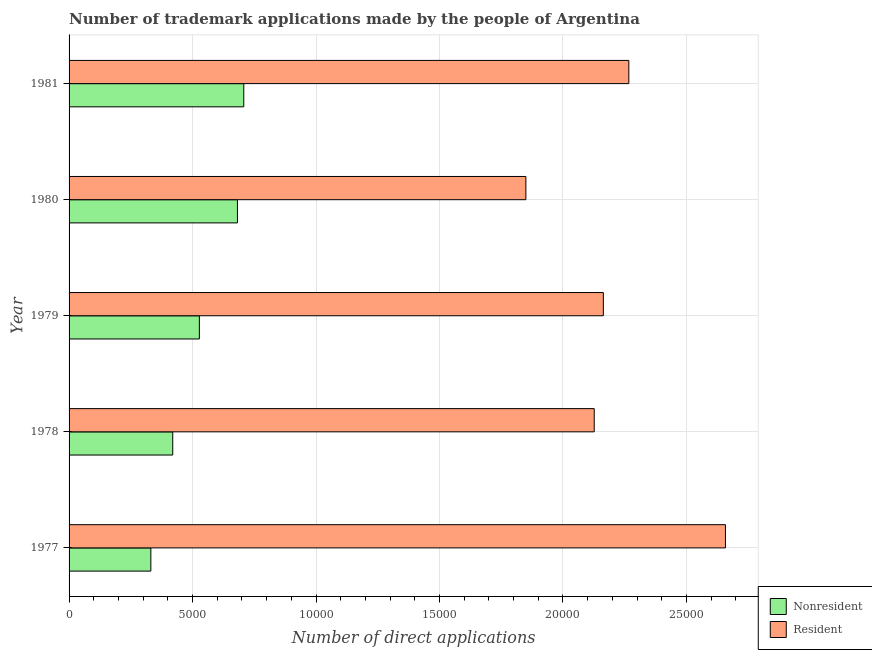How many groups of bars are there?
Your answer should be compact. 5. How many bars are there on the 5th tick from the bottom?
Offer a terse response. 2. What is the label of the 2nd group of bars from the top?
Your answer should be compact. 1980. What is the number of trademark applications made by residents in 1977?
Provide a succinct answer. 2.66e+04. Across all years, what is the maximum number of trademark applications made by residents?
Provide a succinct answer. 2.66e+04. Across all years, what is the minimum number of trademark applications made by non residents?
Your answer should be very brief. 3311. In which year was the number of trademark applications made by residents maximum?
Give a very brief answer. 1977. What is the total number of trademark applications made by residents in the graph?
Offer a very short reply. 1.11e+05. What is the difference between the number of trademark applications made by non residents in 1978 and that in 1980?
Your answer should be compact. -2620. What is the difference between the number of trademark applications made by residents in 1977 and the number of trademark applications made by non residents in 1978?
Keep it short and to the point. 2.24e+04. What is the average number of trademark applications made by non residents per year?
Your response must be concise. 5335.6. In the year 1979, what is the difference between the number of trademark applications made by non residents and number of trademark applications made by residents?
Make the answer very short. -1.64e+04. What is the ratio of the number of trademark applications made by residents in 1977 to that in 1981?
Your answer should be very brief. 1.17. Is the number of trademark applications made by residents in 1977 less than that in 1978?
Offer a very short reply. No. Is the difference between the number of trademark applications made by non residents in 1979 and 1981 greater than the difference between the number of trademark applications made by residents in 1979 and 1981?
Keep it short and to the point. No. What is the difference between the highest and the second highest number of trademark applications made by residents?
Ensure brevity in your answer.  3912. What is the difference between the highest and the lowest number of trademark applications made by residents?
Give a very brief answer. 8081. Is the sum of the number of trademark applications made by non residents in 1978 and 1981 greater than the maximum number of trademark applications made by residents across all years?
Offer a terse response. No. What does the 2nd bar from the top in 1977 represents?
Ensure brevity in your answer.  Nonresident. What does the 1st bar from the bottom in 1979 represents?
Provide a short and direct response. Nonresident. How many years are there in the graph?
Your answer should be very brief. 5. Does the graph contain any zero values?
Offer a terse response. No. How many legend labels are there?
Your response must be concise. 2. How are the legend labels stacked?
Keep it short and to the point. Vertical. What is the title of the graph?
Make the answer very short. Number of trademark applications made by the people of Argentina. What is the label or title of the X-axis?
Your answer should be very brief. Number of direct applications. What is the Number of direct applications of Nonresident in 1977?
Your answer should be very brief. 3311. What is the Number of direct applications of Resident in 1977?
Your answer should be compact. 2.66e+04. What is the Number of direct applications of Nonresident in 1978?
Give a very brief answer. 4198. What is the Number of direct applications of Resident in 1978?
Offer a very short reply. 2.13e+04. What is the Number of direct applications in Nonresident in 1979?
Give a very brief answer. 5276. What is the Number of direct applications in Resident in 1979?
Offer a very short reply. 2.16e+04. What is the Number of direct applications in Nonresident in 1980?
Your answer should be compact. 6818. What is the Number of direct applications in Resident in 1980?
Provide a short and direct response. 1.85e+04. What is the Number of direct applications of Nonresident in 1981?
Provide a succinct answer. 7075. What is the Number of direct applications in Resident in 1981?
Offer a terse response. 2.27e+04. Across all years, what is the maximum Number of direct applications of Nonresident?
Your response must be concise. 7075. Across all years, what is the maximum Number of direct applications of Resident?
Make the answer very short. 2.66e+04. Across all years, what is the minimum Number of direct applications in Nonresident?
Your response must be concise. 3311. Across all years, what is the minimum Number of direct applications in Resident?
Offer a terse response. 1.85e+04. What is the total Number of direct applications of Nonresident in the graph?
Offer a very short reply. 2.67e+04. What is the total Number of direct applications of Resident in the graph?
Give a very brief answer. 1.11e+05. What is the difference between the Number of direct applications in Nonresident in 1977 and that in 1978?
Provide a succinct answer. -887. What is the difference between the Number of direct applications of Resident in 1977 and that in 1978?
Provide a succinct answer. 5313. What is the difference between the Number of direct applications in Nonresident in 1977 and that in 1979?
Give a very brief answer. -1965. What is the difference between the Number of direct applications of Resident in 1977 and that in 1979?
Provide a short and direct response. 4944. What is the difference between the Number of direct applications in Nonresident in 1977 and that in 1980?
Make the answer very short. -3507. What is the difference between the Number of direct applications in Resident in 1977 and that in 1980?
Provide a short and direct response. 8081. What is the difference between the Number of direct applications in Nonresident in 1977 and that in 1981?
Offer a terse response. -3764. What is the difference between the Number of direct applications of Resident in 1977 and that in 1981?
Your response must be concise. 3912. What is the difference between the Number of direct applications of Nonresident in 1978 and that in 1979?
Your answer should be very brief. -1078. What is the difference between the Number of direct applications of Resident in 1978 and that in 1979?
Your answer should be very brief. -369. What is the difference between the Number of direct applications of Nonresident in 1978 and that in 1980?
Offer a very short reply. -2620. What is the difference between the Number of direct applications in Resident in 1978 and that in 1980?
Your response must be concise. 2768. What is the difference between the Number of direct applications in Nonresident in 1978 and that in 1981?
Provide a short and direct response. -2877. What is the difference between the Number of direct applications in Resident in 1978 and that in 1981?
Make the answer very short. -1401. What is the difference between the Number of direct applications in Nonresident in 1979 and that in 1980?
Make the answer very short. -1542. What is the difference between the Number of direct applications in Resident in 1979 and that in 1980?
Ensure brevity in your answer.  3137. What is the difference between the Number of direct applications of Nonresident in 1979 and that in 1981?
Ensure brevity in your answer.  -1799. What is the difference between the Number of direct applications in Resident in 1979 and that in 1981?
Give a very brief answer. -1032. What is the difference between the Number of direct applications in Nonresident in 1980 and that in 1981?
Your answer should be compact. -257. What is the difference between the Number of direct applications in Resident in 1980 and that in 1981?
Provide a succinct answer. -4169. What is the difference between the Number of direct applications in Nonresident in 1977 and the Number of direct applications in Resident in 1978?
Make the answer very short. -1.80e+04. What is the difference between the Number of direct applications of Nonresident in 1977 and the Number of direct applications of Resident in 1979?
Your answer should be very brief. -1.83e+04. What is the difference between the Number of direct applications of Nonresident in 1977 and the Number of direct applications of Resident in 1980?
Offer a terse response. -1.52e+04. What is the difference between the Number of direct applications in Nonresident in 1977 and the Number of direct applications in Resident in 1981?
Your answer should be very brief. -1.94e+04. What is the difference between the Number of direct applications in Nonresident in 1978 and the Number of direct applications in Resident in 1979?
Ensure brevity in your answer.  -1.74e+04. What is the difference between the Number of direct applications of Nonresident in 1978 and the Number of direct applications of Resident in 1980?
Provide a short and direct response. -1.43e+04. What is the difference between the Number of direct applications in Nonresident in 1978 and the Number of direct applications in Resident in 1981?
Your answer should be very brief. -1.85e+04. What is the difference between the Number of direct applications in Nonresident in 1979 and the Number of direct applications in Resident in 1980?
Offer a very short reply. -1.32e+04. What is the difference between the Number of direct applications of Nonresident in 1979 and the Number of direct applications of Resident in 1981?
Provide a short and direct response. -1.74e+04. What is the difference between the Number of direct applications in Nonresident in 1980 and the Number of direct applications in Resident in 1981?
Provide a short and direct response. -1.58e+04. What is the average Number of direct applications in Nonresident per year?
Offer a very short reply. 5335.6. What is the average Number of direct applications of Resident per year?
Ensure brevity in your answer.  2.21e+04. In the year 1977, what is the difference between the Number of direct applications of Nonresident and Number of direct applications of Resident?
Make the answer very short. -2.33e+04. In the year 1978, what is the difference between the Number of direct applications in Nonresident and Number of direct applications in Resident?
Provide a short and direct response. -1.71e+04. In the year 1979, what is the difference between the Number of direct applications of Nonresident and Number of direct applications of Resident?
Offer a terse response. -1.64e+04. In the year 1980, what is the difference between the Number of direct applications of Nonresident and Number of direct applications of Resident?
Your answer should be very brief. -1.17e+04. In the year 1981, what is the difference between the Number of direct applications of Nonresident and Number of direct applications of Resident?
Your response must be concise. -1.56e+04. What is the ratio of the Number of direct applications of Nonresident in 1977 to that in 1978?
Ensure brevity in your answer.  0.79. What is the ratio of the Number of direct applications in Resident in 1977 to that in 1978?
Make the answer very short. 1.25. What is the ratio of the Number of direct applications of Nonresident in 1977 to that in 1979?
Your answer should be compact. 0.63. What is the ratio of the Number of direct applications in Resident in 1977 to that in 1979?
Provide a short and direct response. 1.23. What is the ratio of the Number of direct applications in Nonresident in 1977 to that in 1980?
Give a very brief answer. 0.49. What is the ratio of the Number of direct applications of Resident in 1977 to that in 1980?
Offer a very short reply. 1.44. What is the ratio of the Number of direct applications in Nonresident in 1977 to that in 1981?
Make the answer very short. 0.47. What is the ratio of the Number of direct applications of Resident in 1977 to that in 1981?
Offer a terse response. 1.17. What is the ratio of the Number of direct applications in Nonresident in 1978 to that in 1979?
Your answer should be very brief. 0.8. What is the ratio of the Number of direct applications of Resident in 1978 to that in 1979?
Provide a succinct answer. 0.98. What is the ratio of the Number of direct applications in Nonresident in 1978 to that in 1980?
Offer a terse response. 0.62. What is the ratio of the Number of direct applications in Resident in 1978 to that in 1980?
Provide a short and direct response. 1.15. What is the ratio of the Number of direct applications of Nonresident in 1978 to that in 1981?
Your answer should be very brief. 0.59. What is the ratio of the Number of direct applications in Resident in 1978 to that in 1981?
Ensure brevity in your answer.  0.94. What is the ratio of the Number of direct applications of Nonresident in 1979 to that in 1980?
Make the answer very short. 0.77. What is the ratio of the Number of direct applications of Resident in 1979 to that in 1980?
Offer a terse response. 1.17. What is the ratio of the Number of direct applications of Nonresident in 1979 to that in 1981?
Ensure brevity in your answer.  0.75. What is the ratio of the Number of direct applications of Resident in 1979 to that in 1981?
Provide a short and direct response. 0.95. What is the ratio of the Number of direct applications in Nonresident in 1980 to that in 1981?
Offer a terse response. 0.96. What is the ratio of the Number of direct applications of Resident in 1980 to that in 1981?
Offer a terse response. 0.82. What is the difference between the highest and the second highest Number of direct applications in Nonresident?
Your answer should be compact. 257. What is the difference between the highest and the second highest Number of direct applications in Resident?
Your response must be concise. 3912. What is the difference between the highest and the lowest Number of direct applications in Nonresident?
Offer a very short reply. 3764. What is the difference between the highest and the lowest Number of direct applications of Resident?
Keep it short and to the point. 8081. 